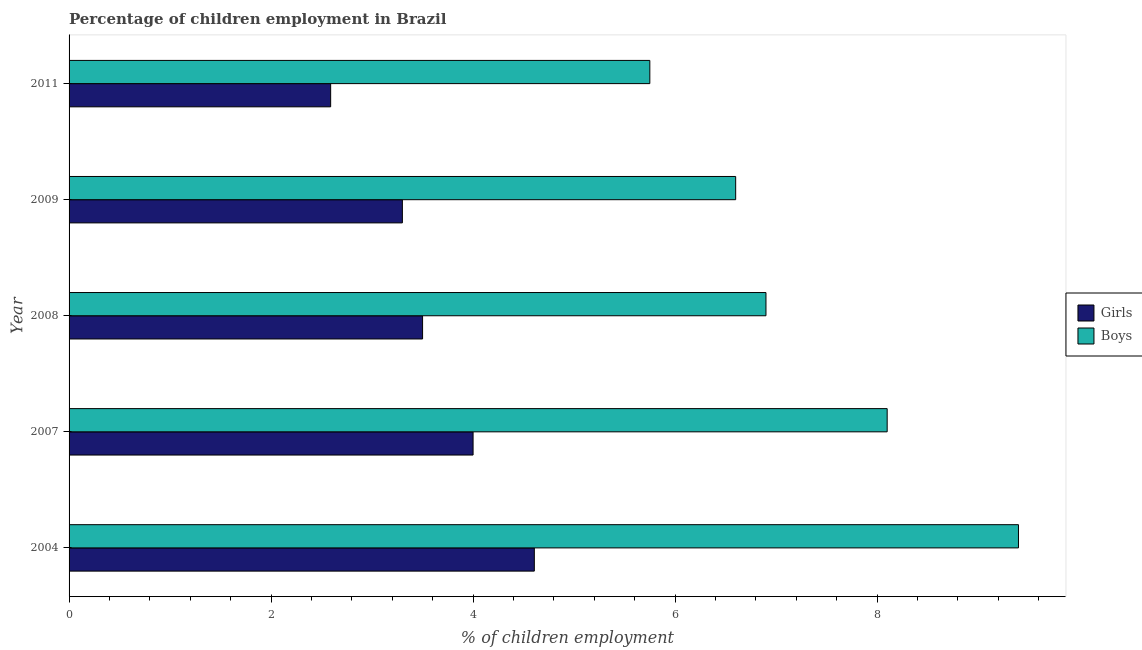How many different coloured bars are there?
Provide a short and direct response. 2. How many groups of bars are there?
Your answer should be compact. 5. Are the number of bars on each tick of the Y-axis equal?
Offer a very short reply. Yes. What is the label of the 2nd group of bars from the top?
Offer a very short reply. 2009. In how many cases, is the number of bars for a given year not equal to the number of legend labels?
Ensure brevity in your answer.  0. Across all years, what is the maximum percentage of employed boys?
Provide a succinct answer. 9.4. Across all years, what is the minimum percentage of employed boys?
Provide a short and direct response. 5.75. In which year was the percentage of employed boys maximum?
Give a very brief answer. 2004. In which year was the percentage of employed girls minimum?
Keep it short and to the point. 2011. What is the total percentage of employed boys in the graph?
Provide a succinct answer. 36.75. What is the difference between the percentage of employed girls in 2009 and the percentage of employed boys in 2011?
Offer a terse response. -2.45. What is the average percentage of employed boys per year?
Offer a very short reply. 7.35. In how many years, is the percentage of employed girls greater than 6 %?
Your response must be concise. 0. What is the ratio of the percentage of employed girls in 2007 to that in 2008?
Provide a short and direct response. 1.14. Is the percentage of employed boys in 2009 less than that in 2011?
Provide a succinct answer. No. What is the difference between the highest and the lowest percentage of employed girls?
Make the answer very short. 2.02. What does the 1st bar from the top in 2008 represents?
Provide a short and direct response. Boys. What does the 2nd bar from the bottom in 2008 represents?
Offer a very short reply. Boys. How many bars are there?
Your answer should be very brief. 10. Are all the bars in the graph horizontal?
Keep it short and to the point. Yes. What is the difference between two consecutive major ticks on the X-axis?
Make the answer very short. 2. Does the graph contain any zero values?
Offer a very short reply. No. Does the graph contain grids?
Provide a succinct answer. No. What is the title of the graph?
Your answer should be compact. Percentage of children employment in Brazil. What is the label or title of the X-axis?
Offer a terse response. % of children employment. What is the label or title of the Y-axis?
Make the answer very short. Year. What is the % of children employment in Girls in 2004?
Offer a terse response. 4.61. What is the % of children employment of Boys in 2007?
Offer a very short reply. 8.1. What is the % of children employment in Boys in 2008?
Ensure brevity in your answer.  6.9. What is the % of children employment of Girls in 2009?
Make the answer very short. 3.3. What is the % of children employment of Boys in 2009?
Ensure brevity in your answer.  6.6. What is the % of children employment of Girls in 2011?
Provide a succinct answer. 2.59. What is the % of children employment in Boys in 2011?
Make the answer very short. 5.75. Across all years, what is the maximum % of children employment in Girls?
Your response must be concise. 4.61. Across all years, what is the maximum % of children employment of Boys?
Your answer should be very brief. 9.4. Across all years, what is the minimum % of children employment in Girls?
Provide a succinct answer. 2.59. Across all years, what is the minimum % of children employment of Boys?
Provide a short and direct response. 5.75. What is the total % of children employment of Girls in the graph?
Make the answer very short. 18. What is the total % of children employment of Boys in the graph?
Give a very brief answer. 36.75. What is the difference between the % of children employment of Girls in 2004 and that in 2007?
Keep it short and to the point. 0.61. What is the difference between the % of children employment in Boys in 2004 and that in 2007?
Keep it short and to the point. 1.3. What is the difference between the % of children employment in Girls in 2004 and that in 2008?
Offer a very short reply. 1.11. What is the difference between the % of children employment in Girls in 2004 and that in 2009?
Ensure brevity in your answer.  1.31. What is the difference between the % of children employment in Boys in 2004 and that in 2009?
Make the answer very short. 2.8. What is the difference between the % of children employment in Girls in 2004 and that in 2011?
Offer a very short reply. 2.02. What is the difference between the % of children employment of Boys in 2004 and that in 2011?
Your answer should be very brief. 3.65. What is the difference between the % of children employment in Girls in 2007 and that in 2008?
Offer a terse response. 0.5. What is the difference between the % of children employment of Boys in 2007 and that in 2008?
Make the answer very short. 1.2. What is the difference between the % of children employment of Girls in 2007 and that in 2011?
Your answer should be compact. 1.41. What is the difference between the % of children employment in Boys in 2007 and that in 2011?
Make the answer very short. 2.35. What is the difference between the % of children employment of Boys in 2008 and that in 2009?
Provide a succinct answer. 0.3. What is the difference between the % of children employment in Girls in 2008 and that in 2011?
Your answer should be compact. 0.91. What is the difference between the % of children employment in Boys in 2008 and that in 2011?
Your response must be concise. 1.15. What is the difference between the % of children employment in Girls in 2009 and that in 2011?
Ensure brevity in your answer.  0.71. What is the difference between the % of children employment in Girls in 2004 and the % of children employment in Boys in 2007?
Your answer should be very brief. -3.49. What is the difference between the % of children employment in Girls in 2004 and the % of children employment in Boys in 2008?
Keep it short and to the point. -2.29. What is the difference between the % of children employment of Girls in 2004 and the % of children employment of Boys in 2009?
Your response must be concise. -1.99. What is the difference between the % of children employment of Girls in 2004 and the % of children employment of Boys in 2011?
Keep it short and to the point. -1.14. What is the difference between the % of children employment of Girls in 2007 and the % of children employment of Boys in 2008?
Ensure brevity in your answer.  -2.9. What is the difference between the % of children employment of Girls in 2007 and the % of children employment of Boys in 2009?
Your answer should be compact. -2.6. What is the difference between the % of children employment in Girls in 2007 and the % of children employment in Boys in 2011?
Provide a short and direct response. -1.75. What is the difference between the % of children employment of Girls in 2008 and the % of children employment of Boys in 2009?
Provide a short and direct response. -3.1. What is the difference between the % of children employment in Girls in 2008 and the % of children employment in Boys in 2011?
Your response must be concise. -2.25. What is the difference between the % of children employment in Girls in 2009 and the % of children employment in Boys in 2011?
Provide a short and direct response. -2.45. What is the average % of children employment in Girls per year?
Your answer should be compact. 3.6. What is the average % of children employment in Boys per year?
Provide a short and direct response. 7.35. In the year 2004, what is the difference between the % of children employment of Girls and % of children employment of Boys?
Give a very brief answer. -4.79. In the year 2007, what is the difference between the % of children employment of Girls and % of children employment of Boys?
Your response must be concise. -4.1. In the year 2008, what is the difference between the % of children employment of Girls and % of children employment of Boys?
Provide a short and direct response. -3.4. In the year 2011, what is the difference between the % of children employment in Girls and % of children employment in Boys?
Offer a terse response. -3.16. What is the ratio of the % of children employment of Girls in 2004 to that in 2007?
Offer a very short reply. 1.15. What is the ratio of the % of children employment of Boys in 2004 to that in 2007?
Make the answer very short. 1.16. What is the ratio of the % of children employment of Girls in 2004 to that in 2008?
Keep it short and to the point. 1.32. What is the ratio of the % of children employment in Boys in 2004 to that in 2008?
Offer a terse response. 1.36. What is the ratio of the % of children employment in Girls in 2004 to that in 2009?
Your response must be concise. 1.4. What is the ratio of the % of children employment in Boys in 2004 to that in 2009?
Provide a short and direct response. 1.42. What is the ratio of the % of children employment in Girls in 2004 to that in 2011?
Make the answer very short. 1.78. What is the ratio of the % of children employment in Boys in 2004 to that in 2011?
Give a very brief answer. 1.63. What is the ratio of the % of children employment of Girls in 2007 to that in 2008?
Ensure brevity in your answer.  1.14. What is the ratio of the % of children employment of Boys in 2007 to that in 2008?
Provide a succinct answer. 1.17. What is the ratio of the % of children employment in Girls in 2007 to that in 2009?
Your answer should be very brief. 1.21. What is the ratio of the % of children employment of Boys in 2007 to that in 2009?
Your answer should be compact. 1.23. What is the ratio of the % of children employment in Girls in 2007 to that in 2011?
Ensure brevity in your answer.  1.54. What is the ratio of the % of children employment of Boys in 2007 to that in 2011?
Provide a short and direct response. 1.41. What is the ratio of the % of children employment of Girls in 2008 to that in 2009?
Your answer should be very brief. 1.06. What is the ratio of the % of children employment in Boys in 2008 to that in 2009?
Give a very brief answer. 1.05. What is the ratio of the % of children employment in Girls in 2008 to that in 2011?
Offer a very short reply. 1.35. What is the ratio of the % of children employment of Boys in 2008 to that in 2011?
Your response must be concise. 1.2. What is the ratio of the % of children employment in Girls in 2009 to that in 2011?
Give a very brief answer. 1.27. What is the ratio of the % of children employment in Boys in 2009 to that in 2011?
Offer a very short reply. 1.15. What is the difference between the highest and the second highest % of children employment in Girls?
Offer a terse response. 0.61. What is the difference between the highest and the lowest % of children employment in Girls?
Ensure brevity in your answer.  2.02. What is the difference between the highest and the lowest % of children employment in Boys?
Your answer should be very brief. 3.65. 